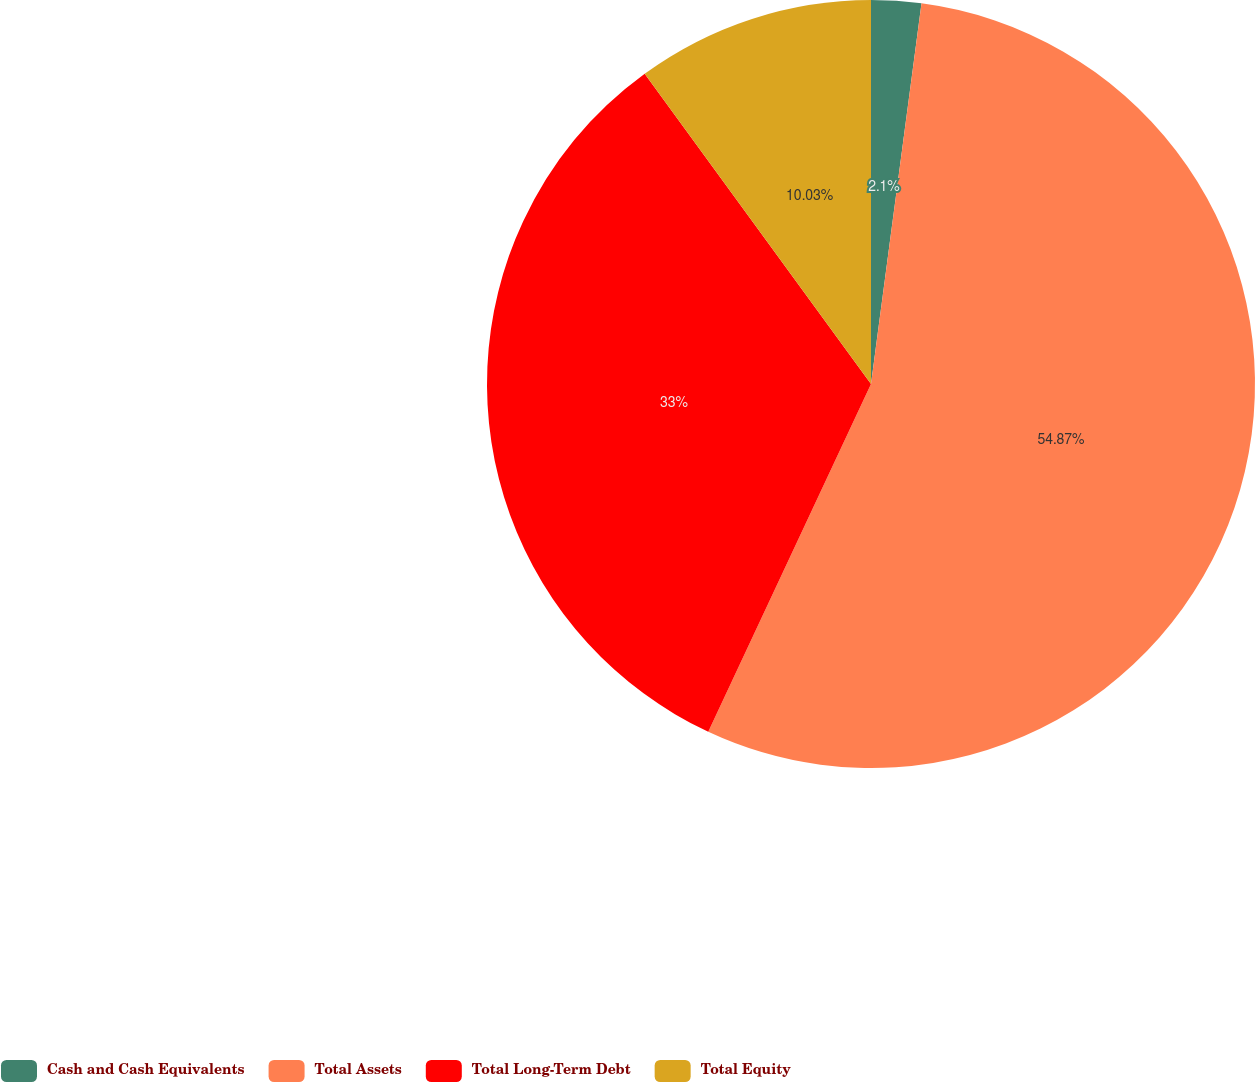<chart> <loc_0><loc_0><loc_500><loc_500><pie_chart><fcel>Cash and Cash Equivalents<fcel>Total Assets<fcel>Total Long-Term Debt<fcel>Total Equity<nl><fcel>2.1%<fcel>54.86%<fcel>33.0%<fcel>10.03%<nl></chart> 